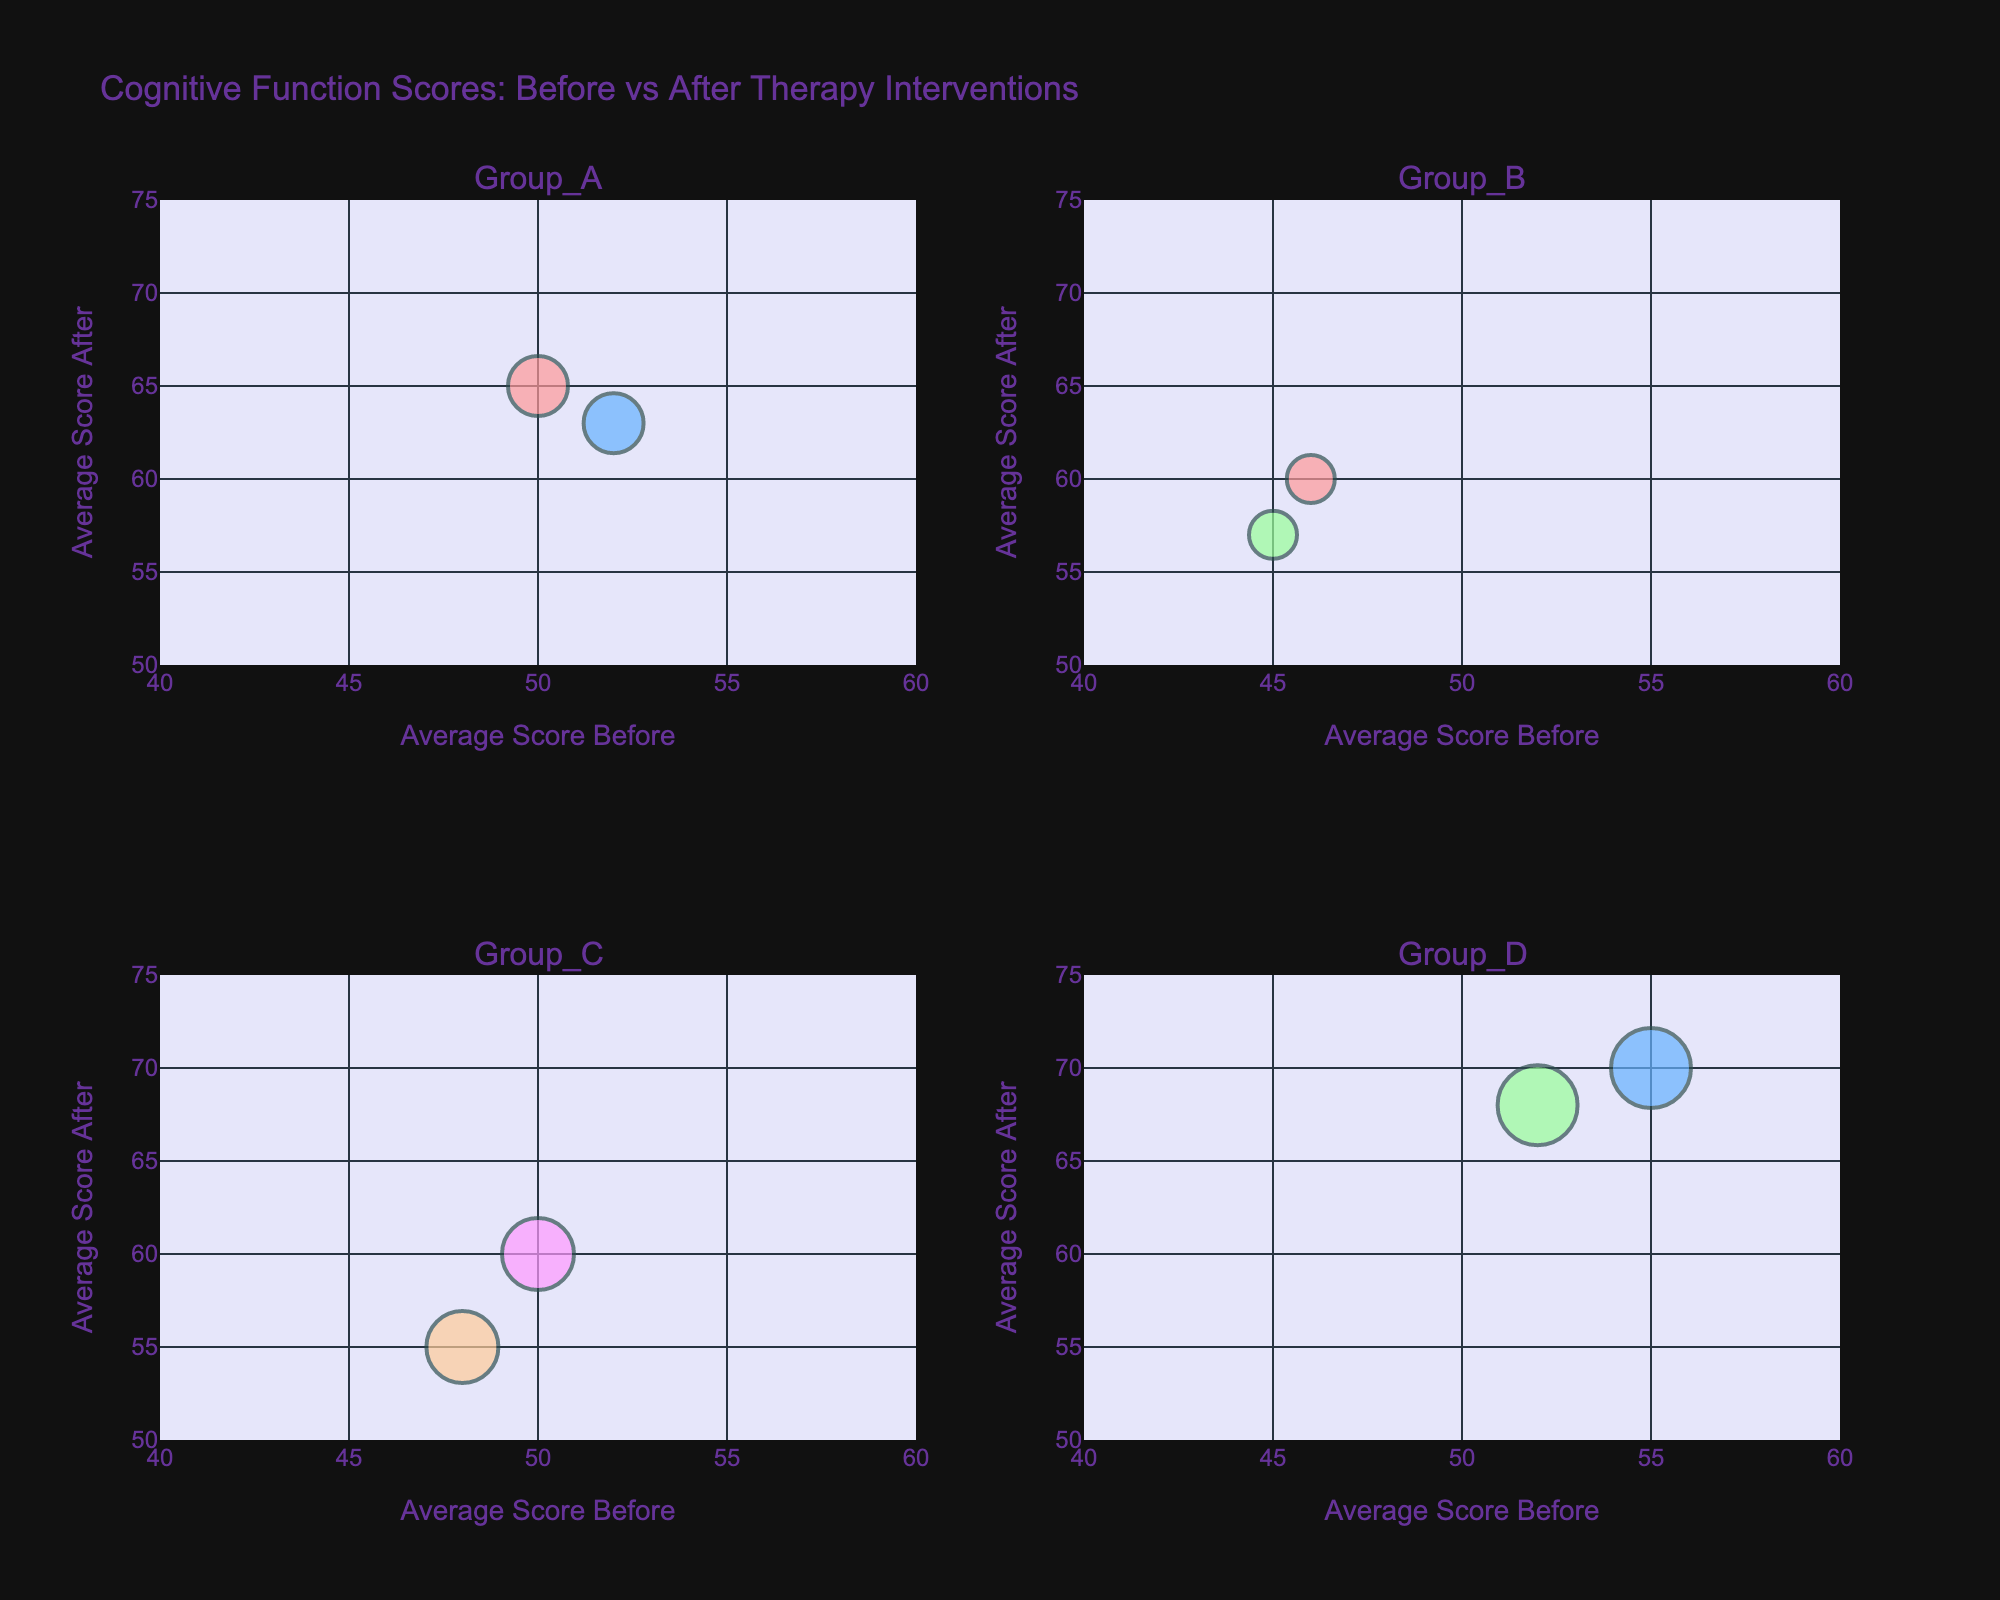What's the title of the figure? The title is displayed at the top of the figure as "Cognitive Function Scores: Before vs After Therapy Interventions."
Answer: Cognitive Function Scores: Before vs After Therapy Interventions How many therapy interventions are shown for Group A? By observing the number of different colored bubbles labeled in the subplot for Group A, there are two distinct therapy interventions.
Answer: 2 Which therapy intervention has the highest average score after therapy in Group D? By looking at the Y-axis values for Group D’s subplot, the highest point corresponds to the bubble with the label "Physical Exercise."
Answer: Physical Exercise What is the average score difference before and after the therapy intervention for Group B, Memory Training? For Group B, Memory Training, the average score before is 45 and after is 57. The difference is calculated as 57 - 45.
Answer: 12 Compare the average scores after therapy intervention for Memory Training in Group B and Physical Exercise in Group D. Which one is higher? The average score after Memory Training in Group B is 57, and for Physical Exercise in Group D is 70. 70 is greater than 57.
Answer: Physical Exercise in Group D Which group has the smallest bubble size and what does it represent? By comparing bubble sizes in all subplots, the smallest bubbles are in Group B where each represents 12 patients.
Answer: Group B What is the average improvement in cognitive function scores after therapy interventions across all groups? Calculate the improvement for each group:  
Group A (Cognitive_Stimulation_Therapy): 65 - 50 = 15  
Group A (Physical_Exercise): 63 - 52 = 11  
Group B (Memory_Training): 57 - 45 = 12  
Group B (Cognitive_Stimulation_Therapy): 60 - 46 = 14  
Group C (Reminiscence_Therapy): 55 - 48 = 7  
Group C (Music_Therapy): 60 - 50 = 10  
Group D (Physical_Exercise): 70 - 55 = 15  
Group D (Memory_Training): 68 - 52 = 16  
Sum of all improvements: 15 + 11 + 12 + 14 + 7 + 10 + 15 + 16 = 100  
Average improvement: 100 / 8
Answer: 12.5 How does the range of average scores before therapy compare to the range of average scores after therapy? The range of average scores before therapy is from 45 (Group B, Memory Training) to 55 (Group D, Physical Exercise), which is 55 - 45 = 10. For after therapy, the range is from 55 (Group C, Reminiscence Therapy) to 70 (Group D, Physical Exercise), which is 70 - 55 = 15.
Answer: Before therapy: 10, After therapy: 15 